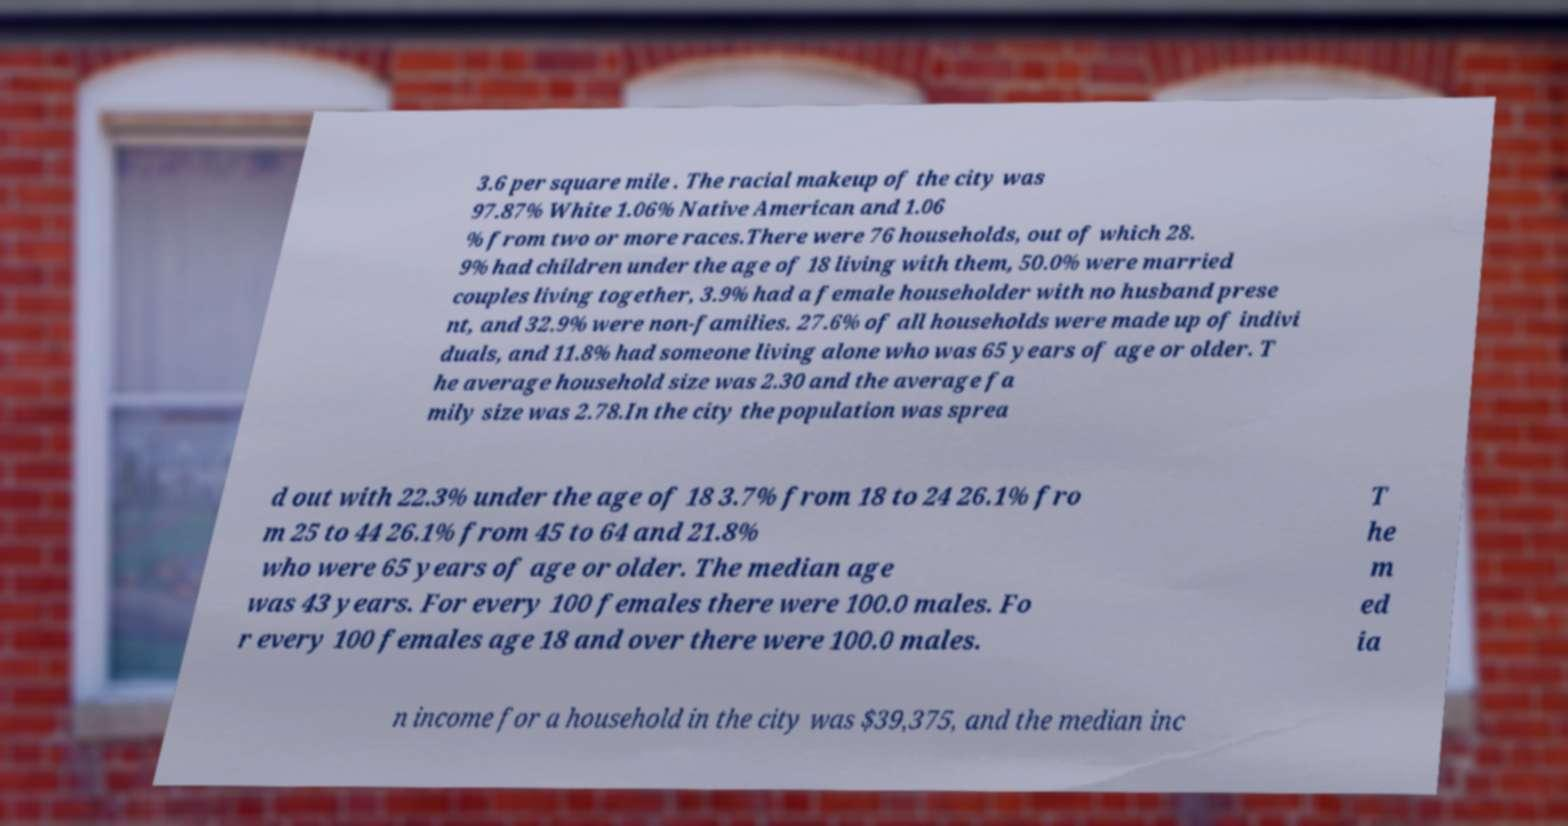Can you read and provide the text displayed in the image?This photo seems to have some interesting text. Can you extract and type it out for me? 3.6 per square mile . The racial makeup of the city was 97.87% White 1.06% Native American and 1.06 % from two or more races.There were 76 households, out of which 28. 9% had children under the age of 18 living with them, 50.0% were married couples living together, 3.9% had a female householder with no husband prese nt, and 32.9% were non-families. 27.6% of all households were made up of indivi duals, and 11.8% had someone living alone who was 65 years of age or older. T he average household size was 2.30 and the average fa mily size was 2.78.In the city the population was sprea d out with 22.3% under the age of 18 3.7% from 18 to 24 26.1% fro m 25 to 44 26.1% from 45 to 64 and 21.8% who were 65 years of age or older. The median age was 43 years. For every 100 females there were 100.0 males. Fo r every 100 females age 18 and over there were 100.0 males. T he m ed ia n income for a household in the city was $39,375, and the median inc 